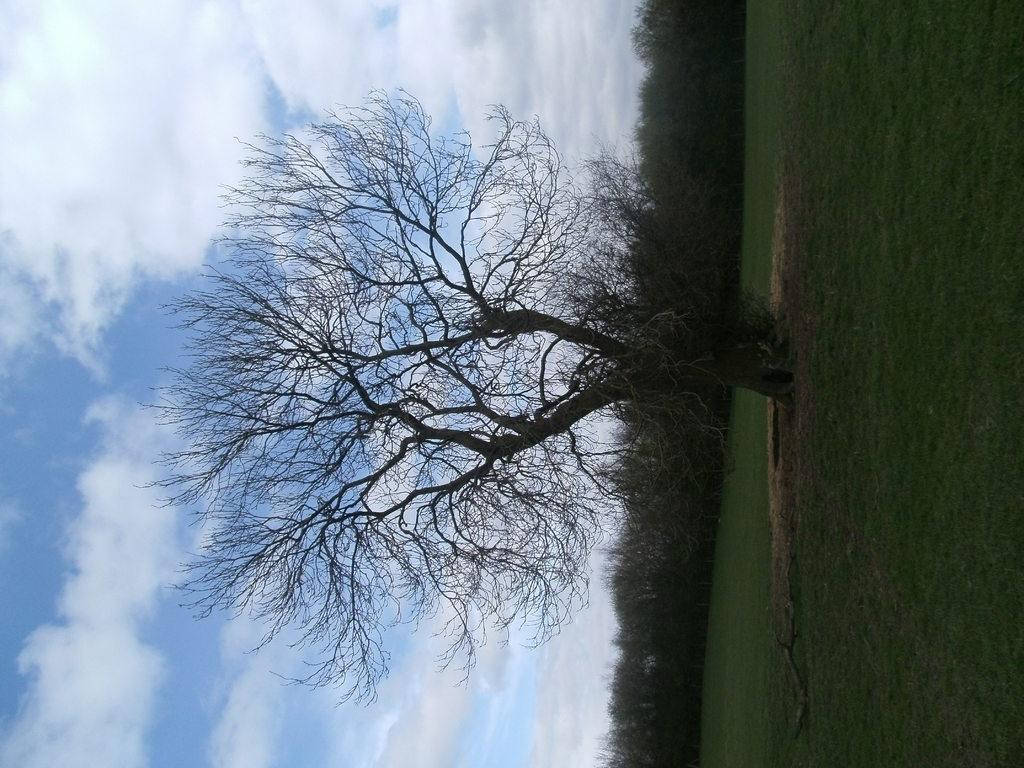Please provide a concise description of this image. In this picture we can see some grass on the ground. There are trees and the cloudy sky. 